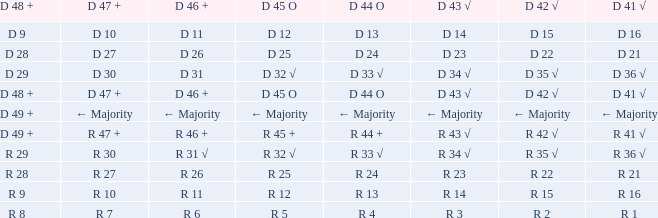What is the value of D 47 + when the value of D 44 O is r 24? R 27. 